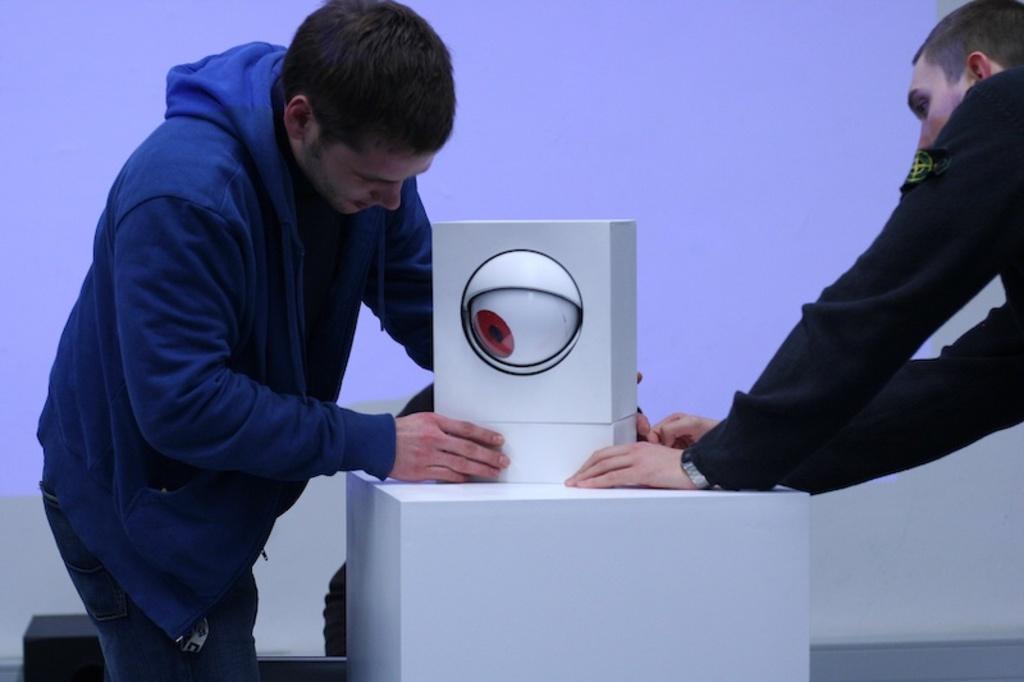Describe this image in one or two sentences. Here we can see two men and there is a box on a platform. On this box we can see an eye. In the background there is a screen. 